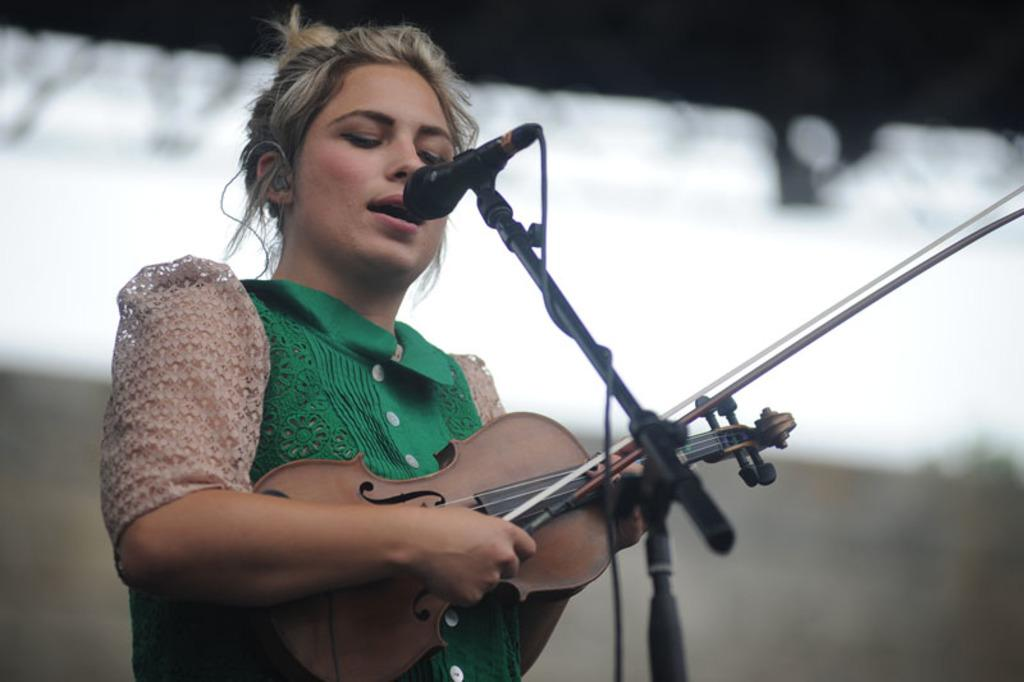What is the main subject of the image? The main subject of the image is a woman. What is the woman doing in the image? The woman is standing, playing a violin, singing a song, and using a microphone. What can be seen in the background of the image? There is a wall in the background of the image. What type of copper material is being used by the woman in the image? There is no copper material present in the image. The woman is using a violin, microphone, and wall, none of which are made of copper. What scene is being depicted in the image? The image is not a scene; it is a photograph of a woman playing a violin, singing, and using a microphone. 